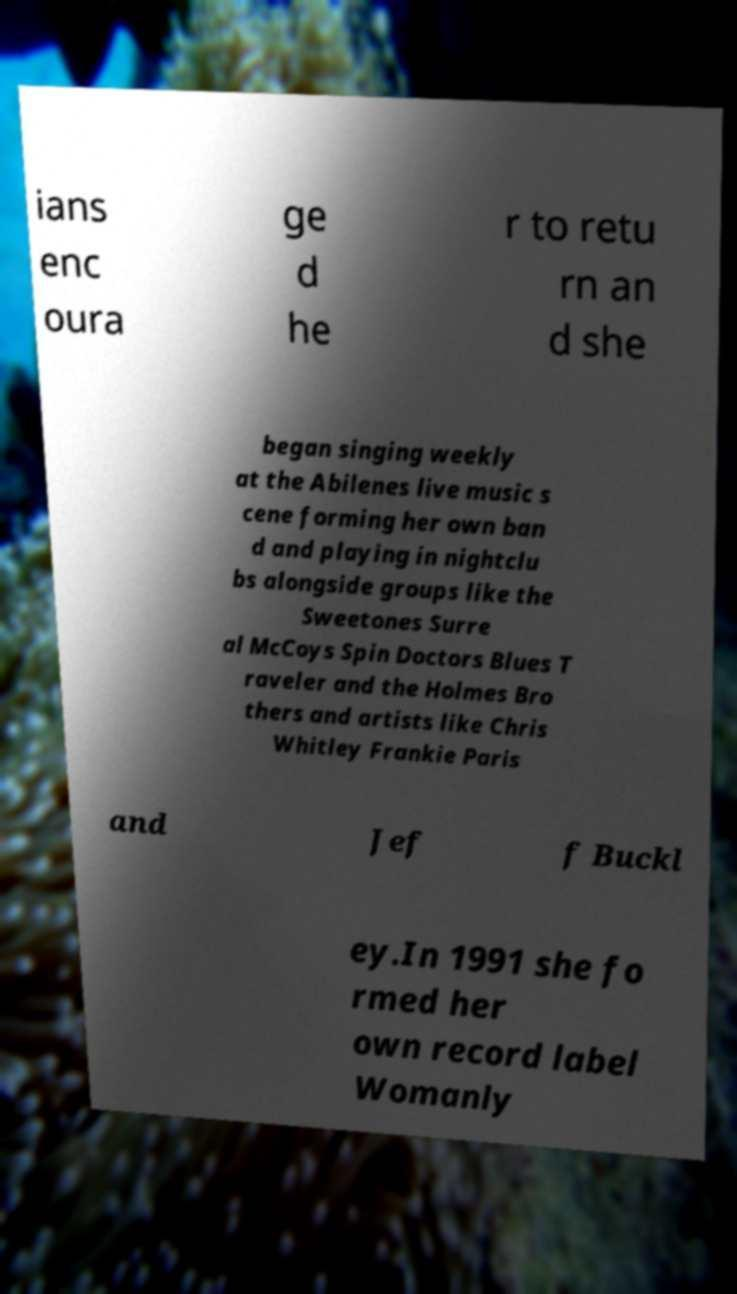I need the written content from this picture converted into text. Can you do that? ians enc oura ge d he r to retu rn an d she began singing weekly at the Abilenes live music s cene forming her own ban d and playing in nightclu bs alongside groups like the Sweetones Surre al McCoys Spin Doctors Blues T raveler and the Holmes Bro thers and artists like Chris Whitley Frankie Paris and Jef f Buckl ey.In 1991 she fo rmed her own record label Womanly 